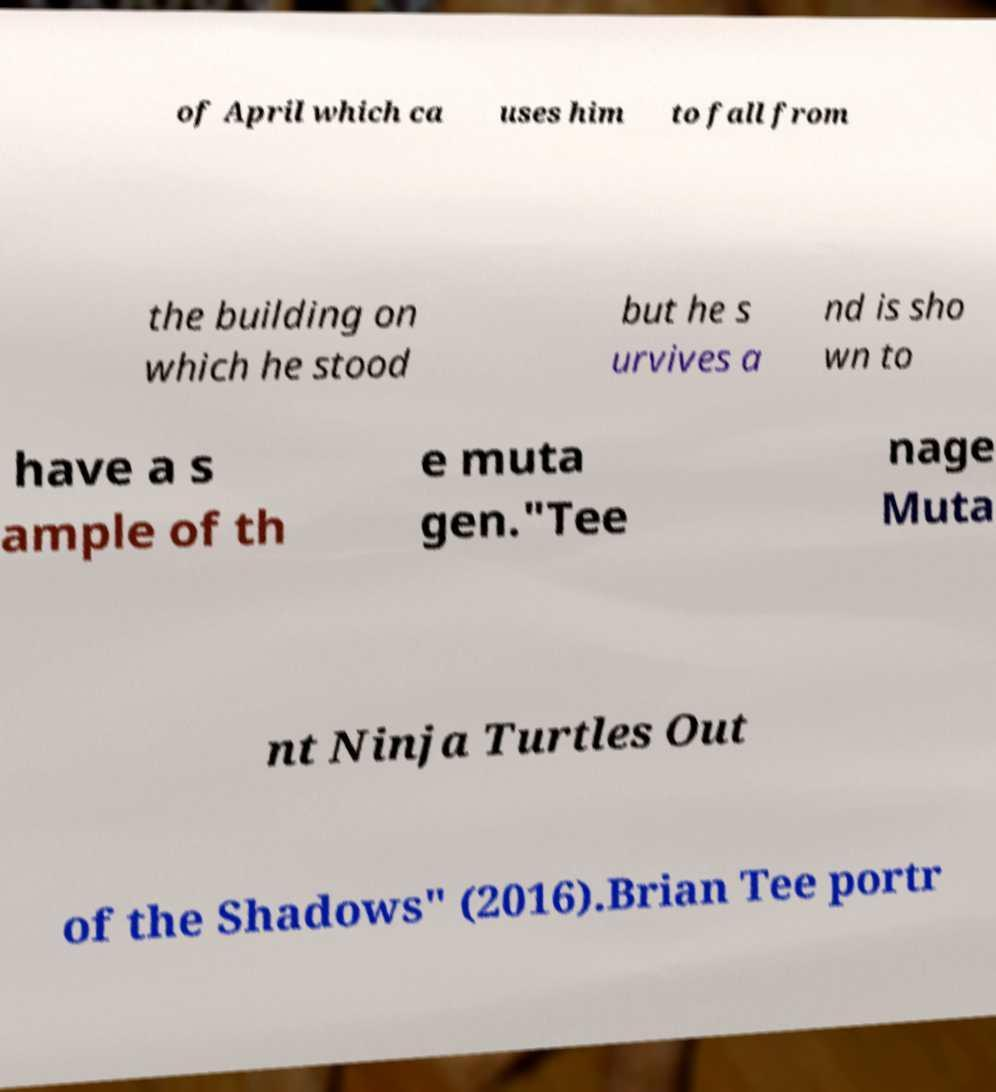Could you extract and type out the text from this image? of April which ca uses him to fall from the building on which he stood but he s urvives a nd is sho wn to have a s ample of th e muta gen."Tee nage Muta nt Ninja Turtles Out of the Shadows" (2016).Brian Tee portr 